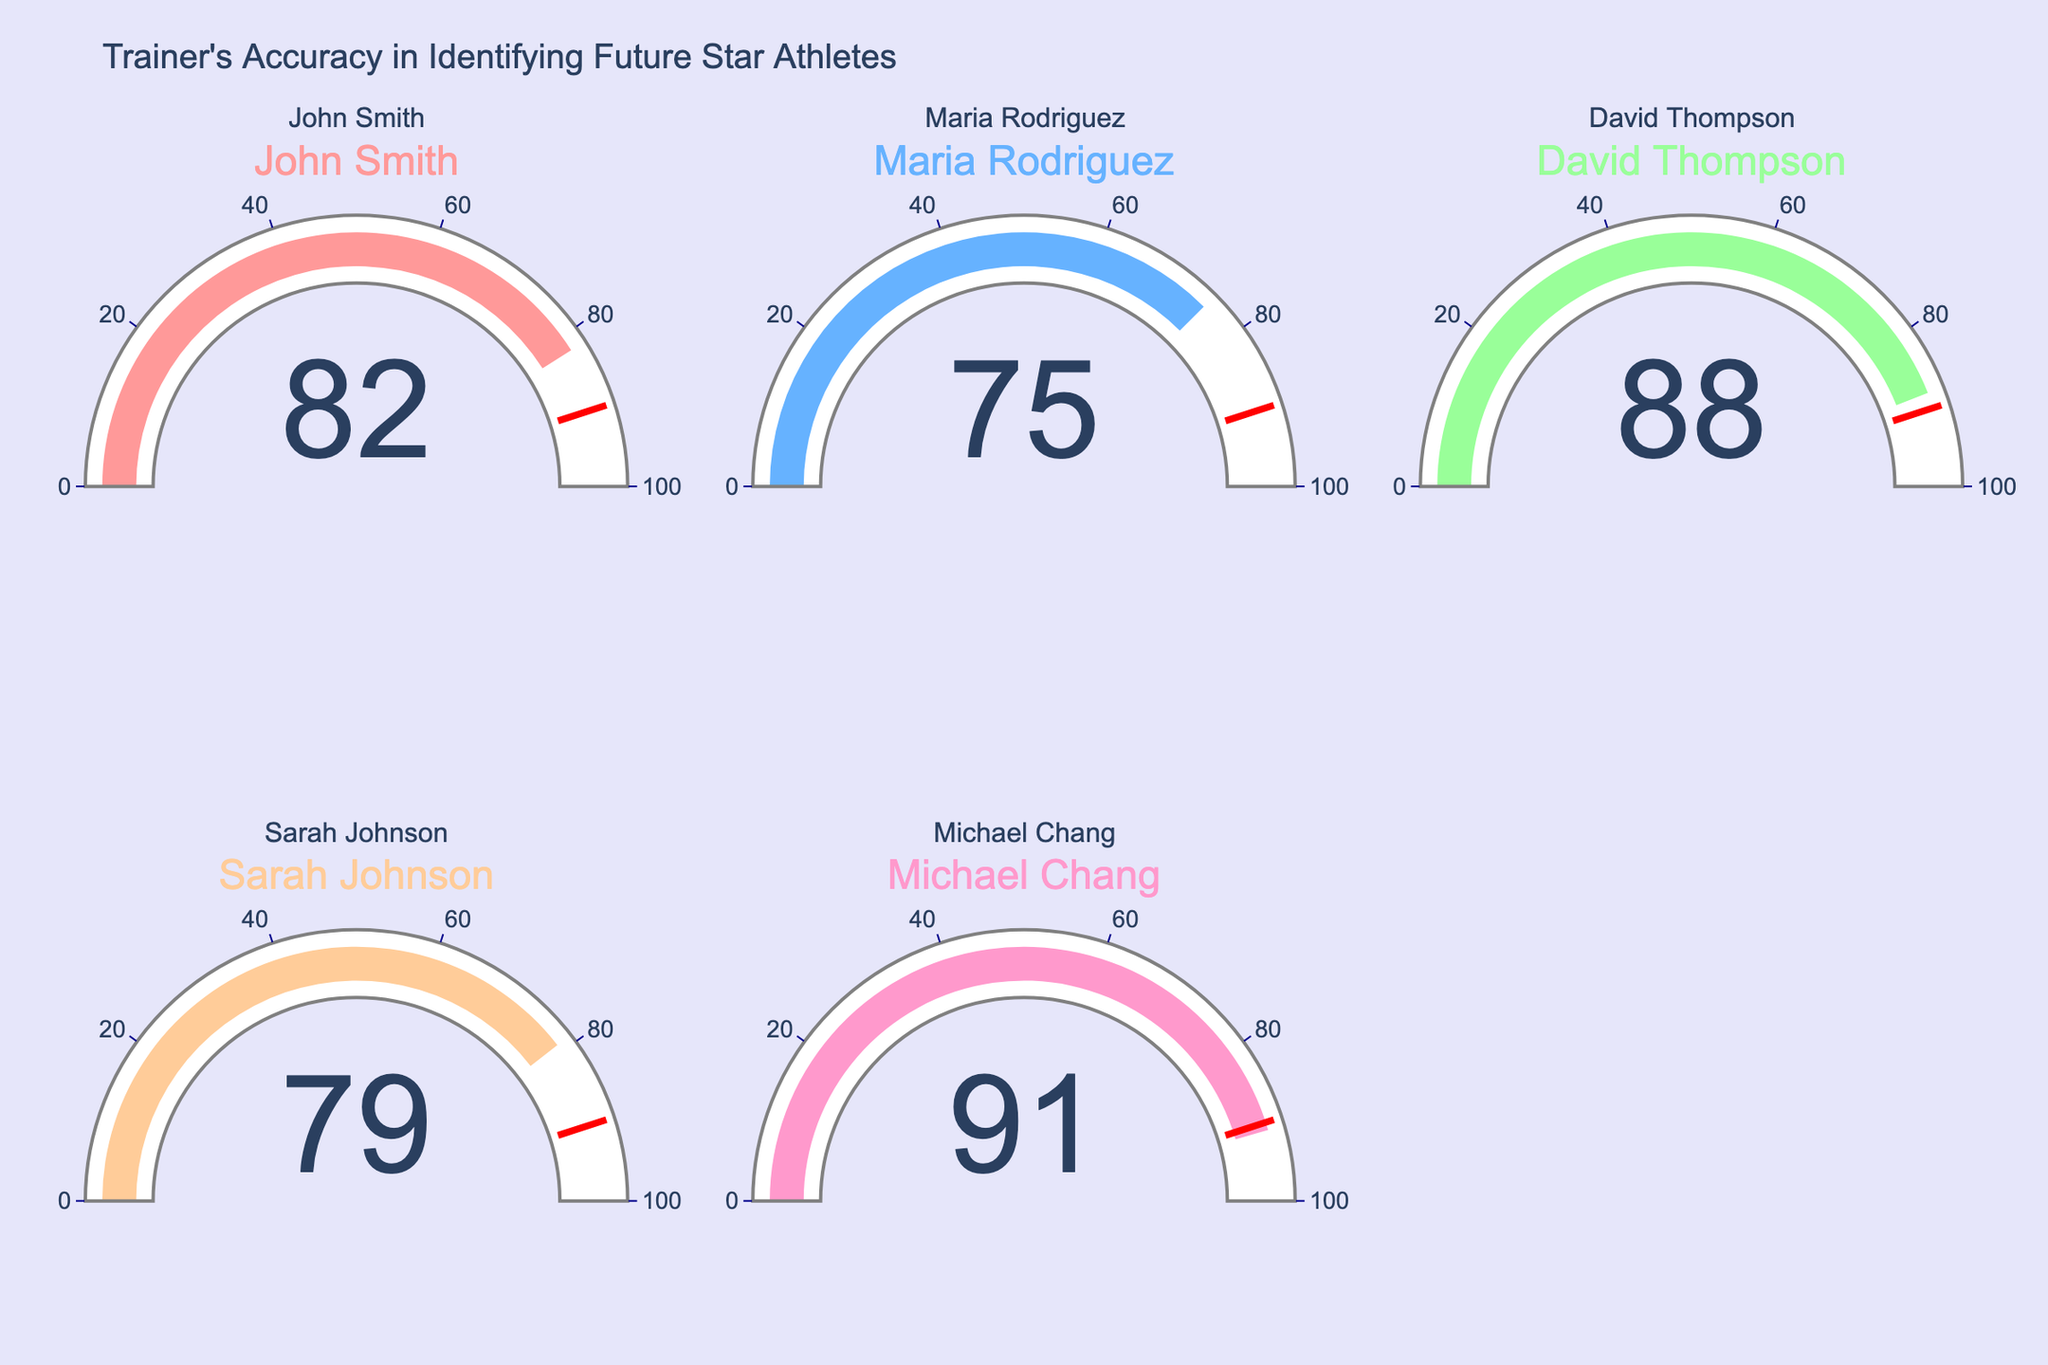What is the accuracy rate of Maria Rodriguez? The gauge chart for Maria Rodriguez shows the value clearly on the gauge itself.
Answer: 75 Which trainer has the highest accuracy rate? The trainer with the highest value displayed on the gauge is the one with the highest accuracy rate. Michael Chang's gauge displays 91.
Answer: Michael Chang What is the difference in accuracy rate between David Thompson and John Smith? David Thompson's gauge shows an accuracy rate of 88, and John Smith's shows an accuracy rate of 82. The difference is calculated by subtracting 82 from 88.
Answer: 6 What is the average accuracy rate of all trainers? The accuracy rates are 82, 75, 88, 79, and 91. Sum these values to get 415. Divide 415 by the number of trainers (5).
Answer: 83 Does any trainer have an accuracy rate above 90? The gauges show the accuracy rates, and Michael Chang's gauge shows 91, which is above 90.
Answer: Yes How many trainers have an accuracy rate below 80? Identify the gauges with values below 80. Maria Rodriguez (75) and Sarah Johnson (79) are the trainers with values below 80. So, there are 2 trainers.
Answer: 2 What is the combined accuracy rate of the two trainers with the lowest rates? The two lowest rates are 75 (Maria Rodriguez) and 79 (Sarah Johnson). Sum these two values: 75 + 79.
Answer: 154 Which trainer has a slightly lower accuracy rate than John Smith? John Smith has an accuracy rate of 82. Sarah Johnson has a rate of 79, which is slightly lower than 82.
Answer: Sarah Johnson Is any trainer's accuracy rate close to the threshold value of 90? The threshold value is marked as 90 on the gauges. Michael Chang has an accuracy rate just above 90 (91), which is closest.
Answer: Yes Are there more trainers with accuracy rates above or below 80? Check the number of trainers above and below 80. Above 80: John Smith (82), David Thompson (88), Michael Chang (91). Below 80: Maria Rodriguez (75), Sarah Johnson (79). There are 3 trainers above 80 and 2 below 80.
Answer: Above 